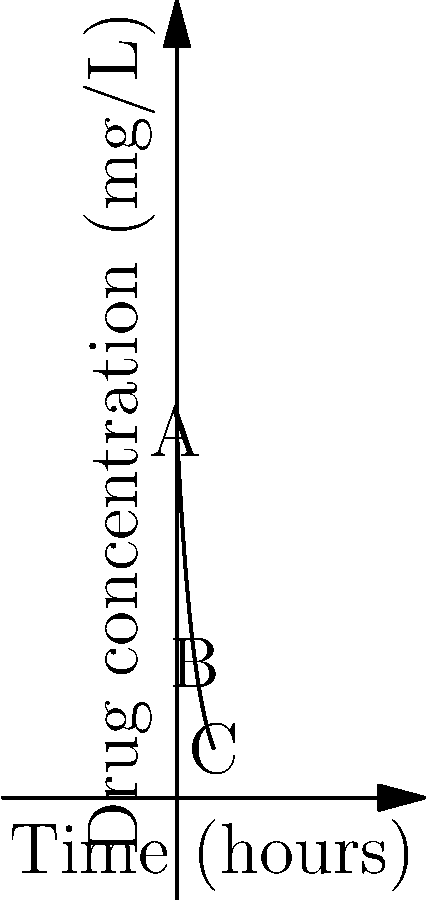The graph shows the concentration of a drug in a patient's bloodstream over time. The concentration $C$ (in mg/L) at time $t$ (in hours) is given by the function $C(t) = 100e^{-0.2t}$. At what time does the rate of change of drug concentration equal -10 mg/L/hour? To solve this problem, we need to follow these steps:

1) First, we need to find the derivative of the concentration function. This represents the rate of change of drug concentration over time.

   $C(t) = 100e^{-0.2t}$
   $C'(t) = 100 \cdot (-0.2) \cdot e^{-0.2t} = -20e^{-0.2t}$

2) Now, we want to find when this rate of change equals -10 mg/L/hour. So we set up the equation:

   $-20e^{-0.2t} = -10$

3) Divide both sides by -20:

   $e^{-0.2t} = 0.5$

4) Take the natural log of both sides:

   $-0.2t = \ln(0.5)$

5) Solve for t:

   $t = -\frac{\ln(0.5)}{0.2} \approx 3.47$ hours

Therefore, the rate of change of drug concentration equals -10 mg/L/hour approximately 3.47 hours after administration.
Answer: 3.47 hours 